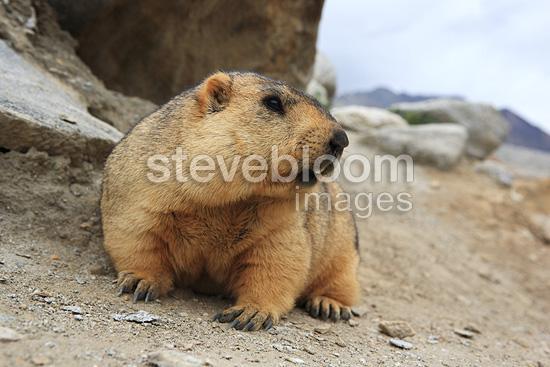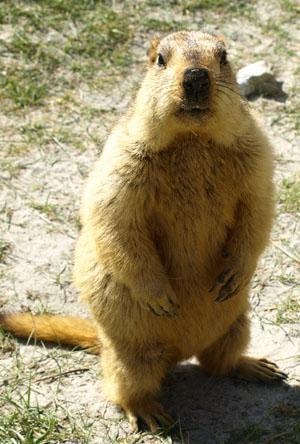The first image is the image on the left, the second image is the image on the right. Examine the images to the left and right. Is the description "a single gopher is standing on hind legs with it's arms down" accurate? Answer yes or no. Yes. 